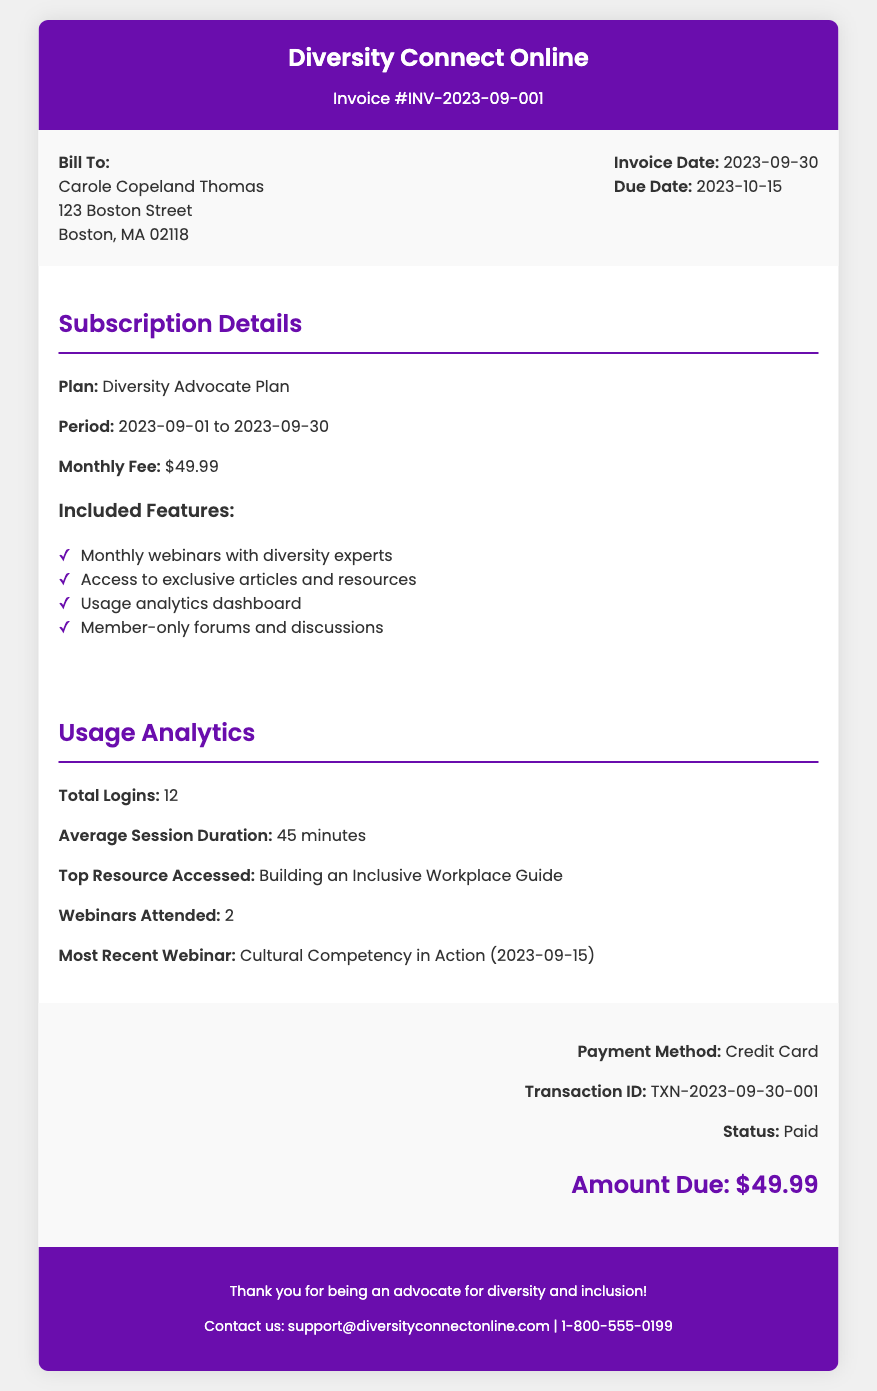What is the invoice number? The invoice number is located near the top of the document under the header section.
Answer: INV-2023-09-001 What is the subscription plan? The subscription plan is mentioned in the subscription details section of the document.
Answer: Diversity Advocate Plan What is the monthly fee? The monthly fee is stated in the subscription details section of the document.
Answer: $49.99 What is the due date for the invoice? The due date is specified in the invoice details section.
Answer: 2023-10-15 How many total logins were recorded? The total logins are reported in the usage analytics section of the document.
Answer: 12 What was the most recently attended webinar? The most recent webinar is mentioned in the usage analytics section, which includes the name and date.
Answer: Cultural Competency in Action (2023-09-15) What payment method was used? The payment method is indicated in the payment info section at the bottom of the document.
Answer: Credit Card What is the status of the transaction? The status of the transaction is located in the payment info section.
Answer: Paid What is the contact email for support? The contact email is presented in the footer of the document.
Answer: support@diversityconnectonline.com 